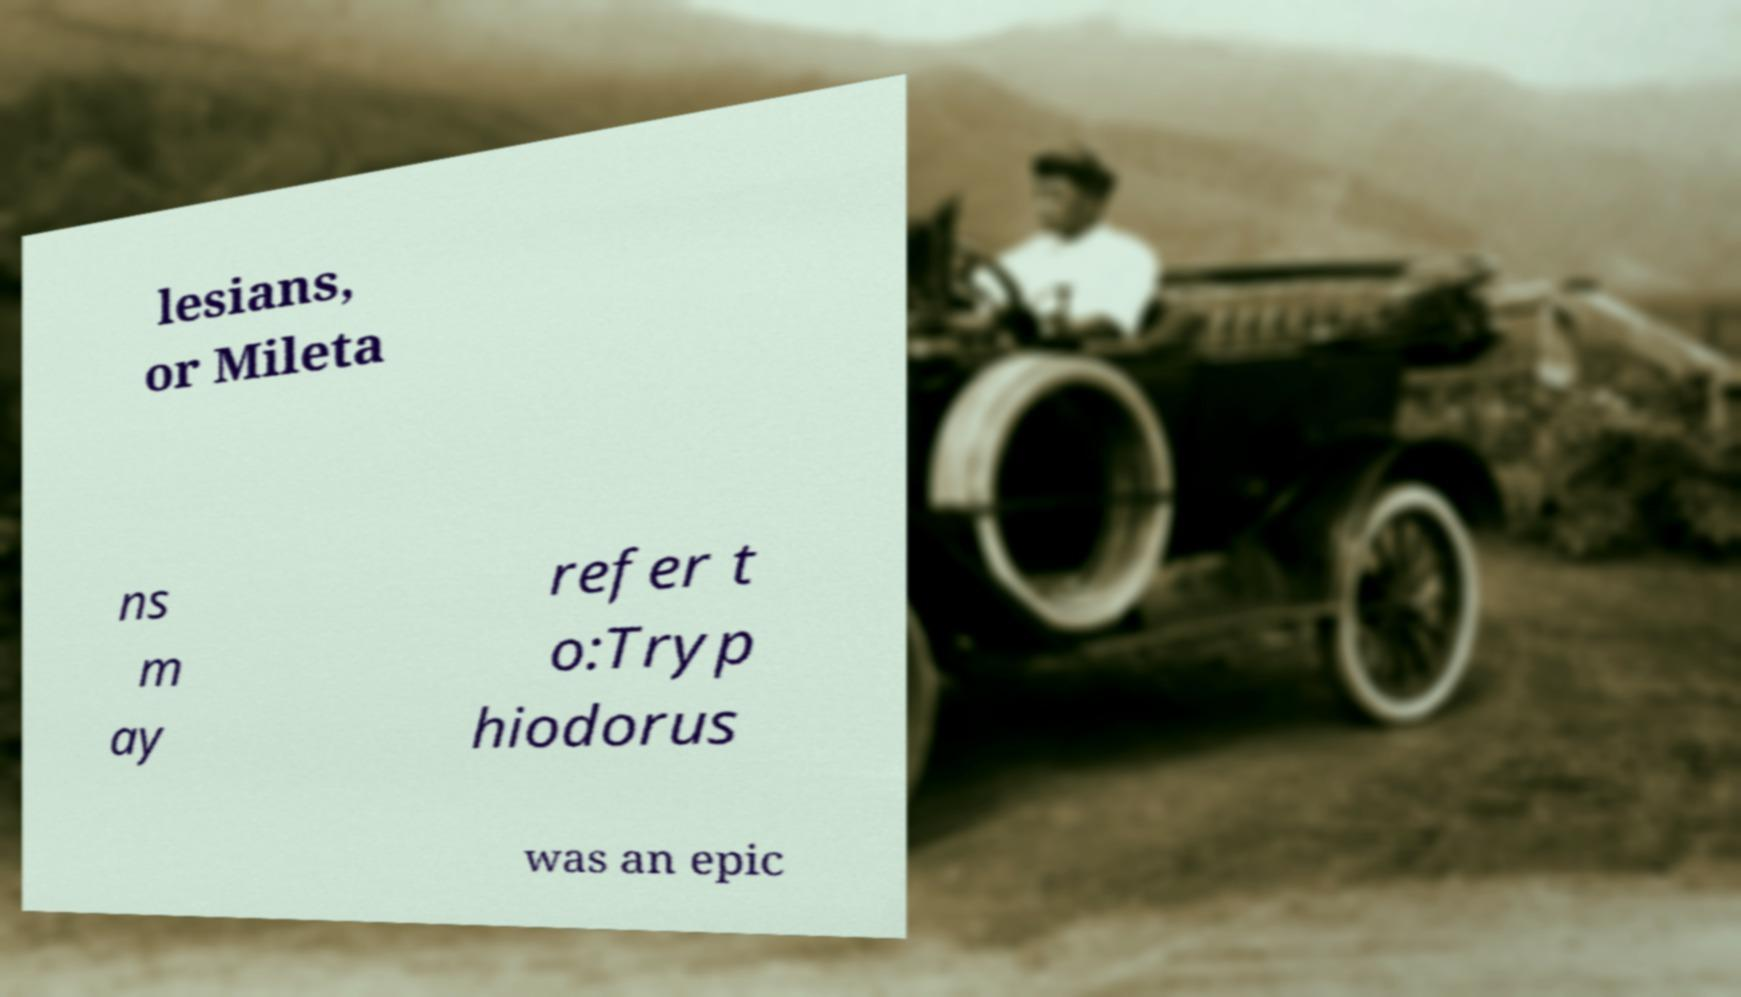Can you read and provide the text displayed in the image?This photo seems to have some interesting text. Can you extract and type it out for me? lesians, or Mileta ns m ay refer t o:Tryp hiodorus was an epic 